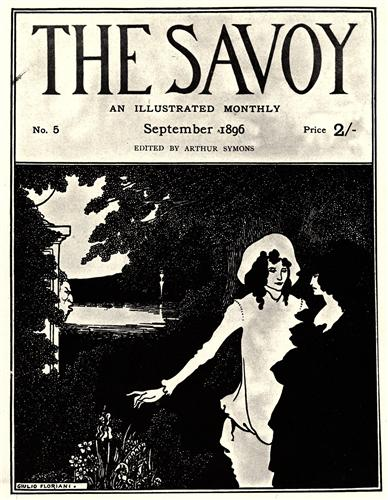What do you see happening in this image? The image is a captivating representation of a late 19th-century magazine cover, specifically "The Savoy", issue number 5 from September 1896. Edited by Arthur Symons, the cover is a beautiful example of the Art Nouveau style, with a monochromatic palette enhancing its timeless elegance. The central focus is a couple standing together in a serene garden setting. The woman, dressed in a flowing white dress, exudes purity and grace, while the man stands protectively beside her, creating a sense of intimacy and connection. The garden itself is lush and tranquil, with a river flowing subtly in the background, adding depth and movement to the scene. Despite being in black and white, the image exudes a sense of tranquility and romance characteristic of the period's art. The magazine's price of 2 shillings offers a quaint reminder of the era. Overall, the composition is a testament to the artistic sensibilities of the late 19th century, capturing the charm and elegance of the Art Nouveau genre. 